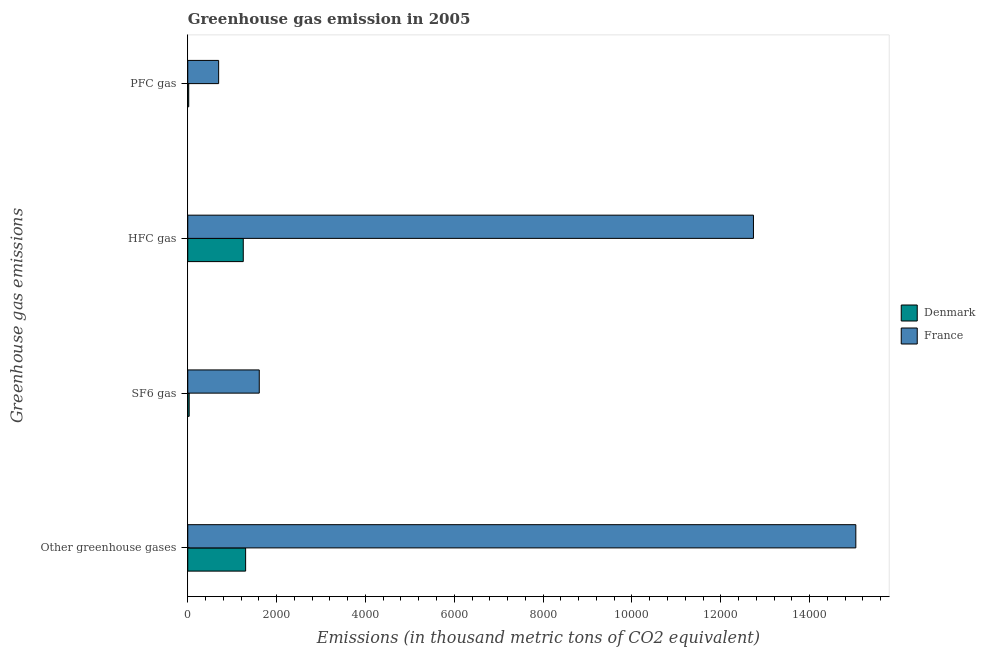How many different coloured bars are there?
Ensure brevity in your answer.  2. How many groups of bars are there?
Ensure brevity in your answer.  4. Are the number of bars per tick equal to the number of legend labels?
Offer a terse response. Yes. Are the number of bars on each tick of the Y-axis equal?
Provide a succinct answer. Yes. How many bars are there on the 1st tick from the top?
Your answer should be very brief. 2. How many bars are there on the 3rd tick from the bottom?
Ensure brevity in your answer.  2. What is the label of the 3rd group of bars from the top?
Offer a terse response. SF6 gas. What is the emission of pfc gas in Denmark?
Offer a very short reply. 21.5. Across all countries, what is the maximum emission of sf6 gas?
Ensure brevity in your answer.  1609.4. Across all countries, what is the minimum emission of hfc gas?
Ensure brevity in your answer.  1249.5. In which country was the emission of greenhouse gases minimum?
Offer a very short reply. Denmark. What is the total emission of sf6 gas in the graph?
Offer a terse response. 1640.9. What is the difference between the emission of greenhouse gases in Denmark and that in France?
Your answer should be very brief. -1.37e+04. What is the difference between the emission of greenhouse gases in Denmark and the emission of hfc gas in France?
Make the answer very short. -1.14e+04. What is the average emission of pfc gas per country?
Provide a succinct answer. 358.3. What is the difference between the emission of hfc gas and emission of sf6 gas in France?
Offer a terse response. 1.11e+04. What is the ratio of the emission of hfc gas in Denmark to that in France?
Provide a short and direct response. 0.1. Is the difference between the emission of greenhouse gases in Denmark and France greater than the difference between the emission of sf6 gas in Denmark and France?
Ensure brevity in your answer.  No. What is the difference between the highest and the second highest emission of pfc gas?
Your answer should be compact. 673.6. What is the difference between the highest and the lowest emission of sf6 gas?
Give a very brief answer. 1577.9. Is the sum of the emission of hfc gas in France and Denmark greater than the maximum emission of greenhouse gases across all countries?
Your answer should be very brief. No. Is it the case that in every country, the sum of the emission of sf6 gas and emission of pfc gas is greater than the sum of emission of greenhouse gases and emission of hfc gas?
Keep it short and to the point. No. What does the 2nd bar from the bottom in SF6 gas represents?
Give a very brief answer. France. Is it the case that in every country, the sum of the emission of greenhouse gases and emission of sf6 gas is greater than the emission of hfc gas?
Keep it short and to the point. Yes. Are all the bars in the graph horizontal?
Provide a succinct answer. Yes. What is the difference between two consecutive major ticks on the X-axis?
Offer a very short reply. 2000. Does the graph contain grids?
Ensure brevity in your answer.  No. How many legend labels are there?
Make the answer very short. 2. What is the title of the graph?
Offer a very short reply. Greenhouse gas emission in 2005. Does "Iraq" appear as one of the legend labels in the graph?
Ensure brevity in your answer.  No. What is the label or title of the X-axis?
Offer a very short reply. Emissions (in thousand metric tons of CO2 equivalent). What is the label or title of the Y-axis?
Offer a very short reply. Greenhouse gas emissions. What is the Emissions (in thousand metric tons of CO2 equivalent) of Denmark in Other greenhouse gases?
Your answer should be very brief. 1302.5. What is the Emissions (in thousand metric tons of CO2 equivalent) of France in Other greenhouse gases?
Provide a short and direct response. 1.50e+04. What is the Emissions (in thousand metric tons of CO2 equivalent) of Denmark in SF6 gas?
Keep it short and to the point. 31.5. What is the Emissions (in thousand metric tons of CO2 equivalent) in France in SF6 gas?
Offer a terse response. 1609.4. What is the Emissions (in thousand metric tons of CO2 equivalent) in Denmark in HFC gas?
Give a very brief answer. 1249.5. What is the Emissions (in thousand metric tons of CO2 equivalent) in France in HFC gas?
Provide a short and direct response. 1.27e+04. What is the Emissions (in thousand metric tons of CO2 equivalent) of France in PFC gas?
Provide a succinct answer. 695.1. Across all Greenhouse gas emissions, what is the maximum Emissions (in thousand metric tons of CO2 equivalent) of Denmark?
Offer a very short reply. 1302.5. Across all Greenhouse gas emissions, what is the maximum Emissions (in thousand metric tons of CO2 equivalent) of France?
Offer a terse response. 1.50e+04. Across all Greenhouse gas emissions, what is the minimum Emissions (in thousand metric tons of CO2 equivalent) of France?
Provide a short and direct response. 695.1. What is the total Emissions (in thousand metric tons of CO2 equivalent) in Denmark in the graph?
Keep it short and to the point. 2605. What is the total Emissions (in thousand metric tons of CO2 equivalent) in France in the graph?
Your answer should be very brief. 3.01e+04. What is the difference between the Emissions (in thousand metric tons of CO2 equivalent) of Denmark in Other greenhouse gases and that in SF6 gas?
Provide a short and direct response. 1271. What is the difference between the Emissions (in thousand metric tons of CO2 equivalent) of France in Other greenhouse gases and that in SF6 gas?
Offer a terse response. 1.34e+04. What is the difference between the Emissions (in thousand metric tons of CO2 equivalent) of Denmark in Other greenhouse gases and that in HFC gas?
Give a very brief answer. 53. What is the difference between the Emissions (in thousand metric tons of CO2 equivalent) of France in Other greenhouse gases and that in HFC gas?
Give a very brief answer. 2304.5. What is the difference between the Emissions (in thousand metric tons of CO2 equivalent) of Denmark in Other greenhouse gases and that in PFC gas?
Keep it short and to the point. 1281. What is the difference between the Emissions (in thousand metric tons of CO2 equivalent) in France in Other greenhouse gases and that in PFC gas?
Provide a short and direct response. 1.43e+04. What is the difference between the Emissions (in thousand metric tons of CO2 equivalent) in Denmark in SF6 gas and that in HFC gas?
Your answer should be very brief. -1218. What is the difference between the Emissions (in thousand metric tons of CO2 equivalent) in France in SF6 gas and that in HFC gas?
Provide a short and direct response. -1.11e+04. What is the difference between the Emissions (in thousand metric tons of CO2 equivalent) of France in SF6 gas and that in PFC gas?
Give a very brief answer. 914.3. What is the difference between the Emissions (in thousand metric tons of CO2 equivalent) in Denmark in HFC gas and that in PFC gas?
Make the answer very short. 1228. What is the difference between the Emissions (in thousand metric tons of CO2 equivalent) in France in HFC gas and that in PFC gas?
Keep it short and to the point. 1.20e+04. What is the difference between the Emissions (in thousand metric tons of CO2 equivalent) in Denmark in Other greenhouse gases and the Emissions (in thousand metric tons of CO2 equivalent) in France in SF6 gas?
Your response must be concise. -306.9. What is the difference between the Emissions (in thousand metric tons of CO2 equivalent) in Denmark in Other greenhouse gases and the Emissions (in thousand metric tons of CO2 equivalent) in France in HFC gas?
Offer a very short reply. -1.14e+04. What is the difference between the Emissions (in thousand metric tons of CO2 equivalent) in Denmark in Other greenhouse gases and the Emissions (in thousand metric tons of CO2 equivalent) in France in PFC gas?
Keep it short and to the point. 607.4. What is the difference between the Emissions (in thousand metric tons of CO2 equivalent) of Denmark in SF6 gas and the Emissions (in thousand metric tons of CO2 equivalent) of France in HFC gas?
Make the answer very short. -1.27e+04. What is the difference between the Emissions (in thousand metric tons of CO2 equivalent) in Denmark in SF6 gas and the Emissions (in thousand metric tons of CO2 equivalent) in France in PFC gas?
Offer a terse response. -663.6. What is the difference between the Emissions (in thousand metric tons of CO2 equivalent) in Denmark in HFC gas and the Emissions (in thousand metric tons of CO2 equivalent) in France in PFC gas?
Keep it short and to the point. 554.4. What is the average Emissions (in thousand metric tons of CO2 equivalent) in Denmark per Greenhouse gas emissions?
Give a very brief answer. 651.25. What is the average Emissions (in thousand metric tons of CO2 equivalent) of France per Greenhouse gas emissions?
Your answer should be compact. 7519.6. What is the difference between the Emissions (in thousand metric tons of CO2 equivalent) of Denmark and Emissions (in thousand metric tons of CO2 equivalent) of France in Other greenhouse gases?
Your answer should be compact. -1.37e+04. What is the difference between the Emissions (in thousand metric tons of CO2 equivalent) in Denmark and Emissions (in thousand metric tons of CO2 equivalent) in France in SF6 gas?
Offer a very short reply. -1577.9. What is the difference between the Emissions (in thousand metric tons of CO2 equivalent) of Denmark and Emissions (in thousand metric tons of CO2 equivalent) of France in HFC gas?
Provide a succinct answer. -1.15e+04. What is the difference between the Emissions (in thousand metric tons of CO2 equivalent) of Denmark and Emissions (in thousand metric tons of CO2 equivalent) of France in PFC gas?
Offer a very short reply. -673.6. What is the ratio of the Emissions (in thousand metric tons of CO2 equivalent) of Denmark in Other greenhouse gases to that in SF6 gas?
Your answer should be very brief. 41.35. What is the ratio of the Emissions (in thousand metric tons of CO2 equivalent) of France in Other greenhouse gases to that in SF6 gas?
Offer a very short reply. 9.34. What is the ratio of the Emissions (in thousand metric tons of CO2 equivalent) in Denmark in Other greenhouse gases to that in HFC gas?
Offer a terse response. 1.04. What is the ratio of the Emissions (in thousand metric tons of CO2 equivalent) in France in Other greenhouse gases to that in HFC gas?
Your answer should be compact. 1.18. What is the ratio of the Emissions (in thousand metric tons of CO2 equivalent) in Denmark in Other greenhouse gases to that in PFC gas?
Offer a terse response. 60.58. What is the ratio of the Emissions (in thousand metric tons of CO2 equivalent) of France in Other greenhouse gases to that in PFC gas?
Keep it short and to the point. 21.64. What is the ratio of the Emissions (in thousand metric tons of CO2 equivalent) of Denmark in SF6 gas to that in HFC gas?
Provide a succinct answer. 0.03. What is the ratio of the Emissions (in thousand metric tons of CO2 equivalent) of France in SF6 gas to that in HFC gas?
Your response must be concise. 0.13. What is the ratio of the Emissions (in thousand metric tons of CO2 equivalent) in Denmark in SF6 gas to that in PFC gas?
Provide a succinct answer. 1.47. What is the ratio of the Emissions (in thousand metric tons of CO2 equivalent) in France in SF6 gas to that in PFC gas?
Ensure brevity in your answer.  2.32. What is the ratio of the Emissions (in thousand metric tons of CO2 equivalent) in Denmark in HFC gas to that in PFC gas?
Your answer should be very brief. 58.12. What is the ratio of the Emissions (in thousand metric tons of CO2 equivalent) in France in HFC gas to that in PFC gas?
Make the answer very short. 18.32. What is the difference between the highest and the second highest Emissions (in thousand metric tons of CO2 equivalent) in Denmark?
Keep it short and to the point. 53. What is the difference between the highest and the second highest Emissions (in thousand metric tons of CO2 equivalent) in France?
Provide a succinct answer. 2304.5. What is the difference between the highest and the lowest Emissions (in thousand metric tons of CO2 equivalent) of Denmark?
Provide a succinct answer. 1281. What is the difference between the highest and the lowest Emissions (in thousand metric tons of CO2 equivalent) of France?
Your answer should be very brief. 1.43e+04. 